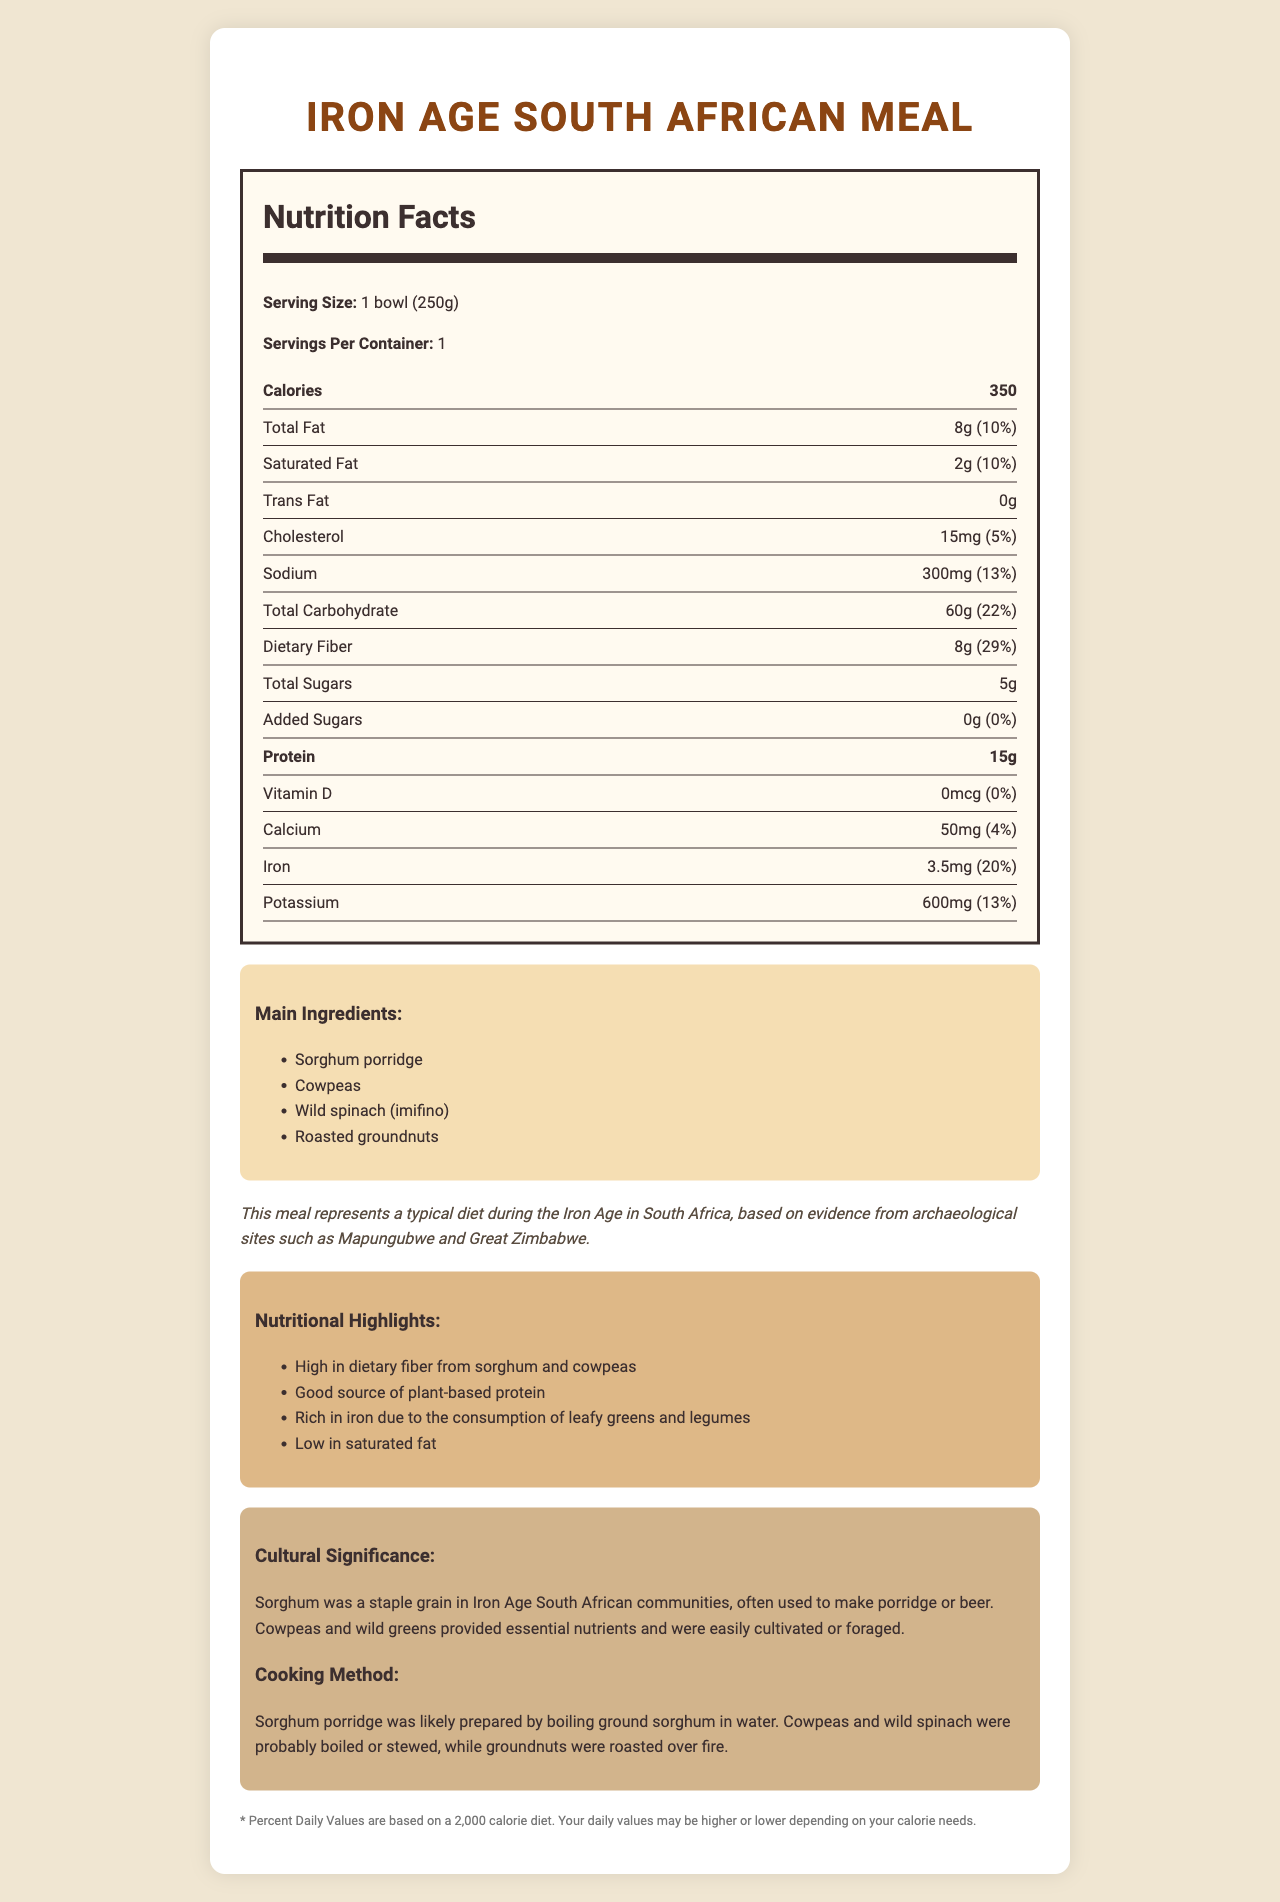what is the serving size of the Iron Age South African Meal? The serving size is clearly stated in the document as "1 bowl (250g)".
Answer: 1 bowl (250g) how many calories are in one serving of this meal? The document specifies that one serving of the Iron Age South African Meal contains 350 calories.
Answer: 350 calories what is the total fat content per serving? The total fat content per serving is listed as 8g.
Answer: 8g how much protein is in a serving? The document shows that there are 15 grams of protein in one serving.
Answer: 15g what is the percent daily value of dietary fiber in this meal? The document states that the dietary fiber has a daily value of 29%.
Answer: 29% what are the main ingredients of this meal? A. Meat, Vegetables, Sorghum B. Sorghum Porridge, Cowpeas, Wild Spinach, Roasted Groundnuts C. Rice, Beans, Fish, Vegetables D. Potatoes, Spinach, Milk, Beans The main ingredients listed in the document are Sorghum Porridge, Cowpeas, Wild Spinach (imifino), and Roasted Groundnuts.
Answer: B what is the cultural significance of Sorghum in this meal? A. It was used to make porridge or beer B. It was a rare delicacy C. It was mainly used for animal feed D. It was not part of the Iron Age diet The document mentions that sorghum was a staple grain in Iron Age South African communities and was often used to make porridge or beer.
Answer: A does this meal contain any trans fat? The document specifies that the trans fat content is 0g.
Answer: No describe the entire document or its main idea. The document gives a comprehensive overview of the nutritional aspects of the meal as well as its archaeological and cultural context.
Answer: The document provides detailed nutritional information about a typical Iron Age South African meal, highlighting its serving size, calorie content, macronutrients, and micronutrients. It also lists the main ingredients and explains their cultural and nutritional significance. Additionally, there is information on how the meal was likely prepared and a disclaimer about daily values based on a 2,000-calorie diet. what kind of cooking method was likely used for this meal? The document describes that the sorghum porridge was boiled, cowpeas and wild spinach were likely boiled or stewed, and groundnuts were roasted over fire.
Answer: Boiling and roasting what is the daily value percentage of iron in this meal? The document indicates that the meal provides 20% of the daily value of iron.
Answer: 20% how much added sugars are in this meal? The document mentions that there are 0 grams of added sugars in this meal.
Answer: 0g is the meal high in saturated fat? The meal is described as low in saturated fat, with only 2g per serving, which is 10% of the daily value.
Answer: No how many servings are in one container? The document explicitly states that there is one serving per container.
Answer: 1 serving where was this type of meal primarily consumed during the Iron Age? While the document provides an archaeological context mentioning Mapungubwe and Great Zimbabwe, it does not specify primary consumption locations.
Answer: Not enough information what is the content of potassium in this meal? The document lists the potassium content as 600mg per serving.
Answer: 600mg 